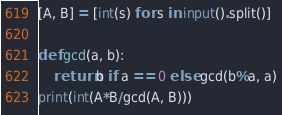Convert code to text. <code><loc_0><loc_0><loc_500><loc_500><_Python_>[A, B] = [int(s) for s in input().split()]

def gcd(a, b):
    return b if a == 0 else gcd(b%a, a)
print(int(A*B/gcd(A, B)))</code> 